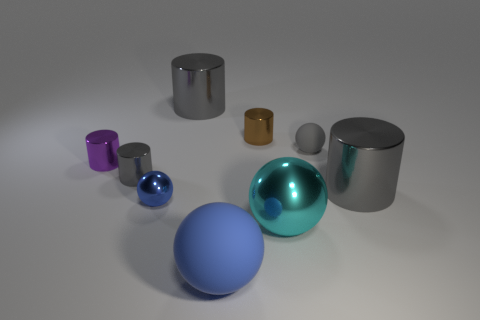Subtract all yellow spheres. How many gray cylinders are left? 3 Subtract all brown cylinders. How many cylinders are left? 4 Subtract all cyan cylinders. Subtract all blue balls. How many cylinders are left? 5 Add 1 small gray shiny balls. How many objects exist? 10 Subtract all balls. How many objects are left? 5 Add 3 brown metal objects. How many brown metal objects are left? 4 Add 8 big shiny spheres. How many big shiny spheres exist? 9 Subtract 0 purple blocks. How many objects are left? 9 Subtract all tiny metallic things. Subtract all brown metal cylinders. How many objects are left? 4 